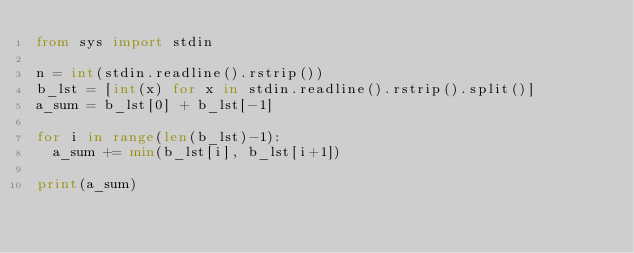<code> <loc_0><loc_0><loc_500><loc_500><_Python_>from sys import stdin

n = int(stdin.readline().rstrip())
b_lst = [int(x) for x in stdin.readline().rstrip().split()]
a_sum = b_lst[0] + b_lst[-1]

for i in range(len(b_lst)-1):
  a_sum += min(b_lst[i], b_lst[i+1])
  
print(a_sum)</code> 